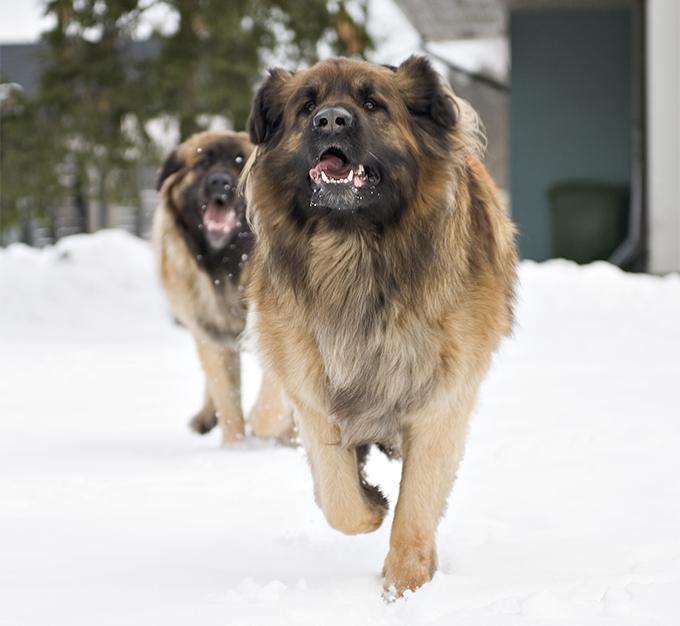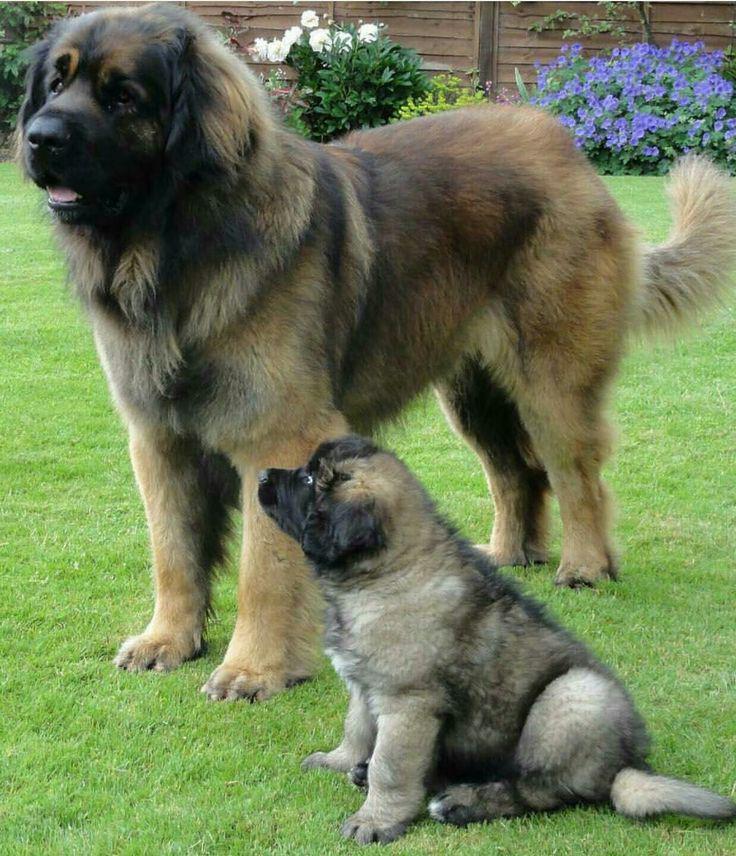The first image is the image on the left, the second image is the image on the right. Analyze the images presented: Is the assertion "At least one person is petting a dog." valid? Answer yes or no. No. The first image is the image on the left, the second image is the image on the right. Given the left and right images, does the statement "There are exactly two dogs in the right image." hold true? Answer yes or no. Yes. 